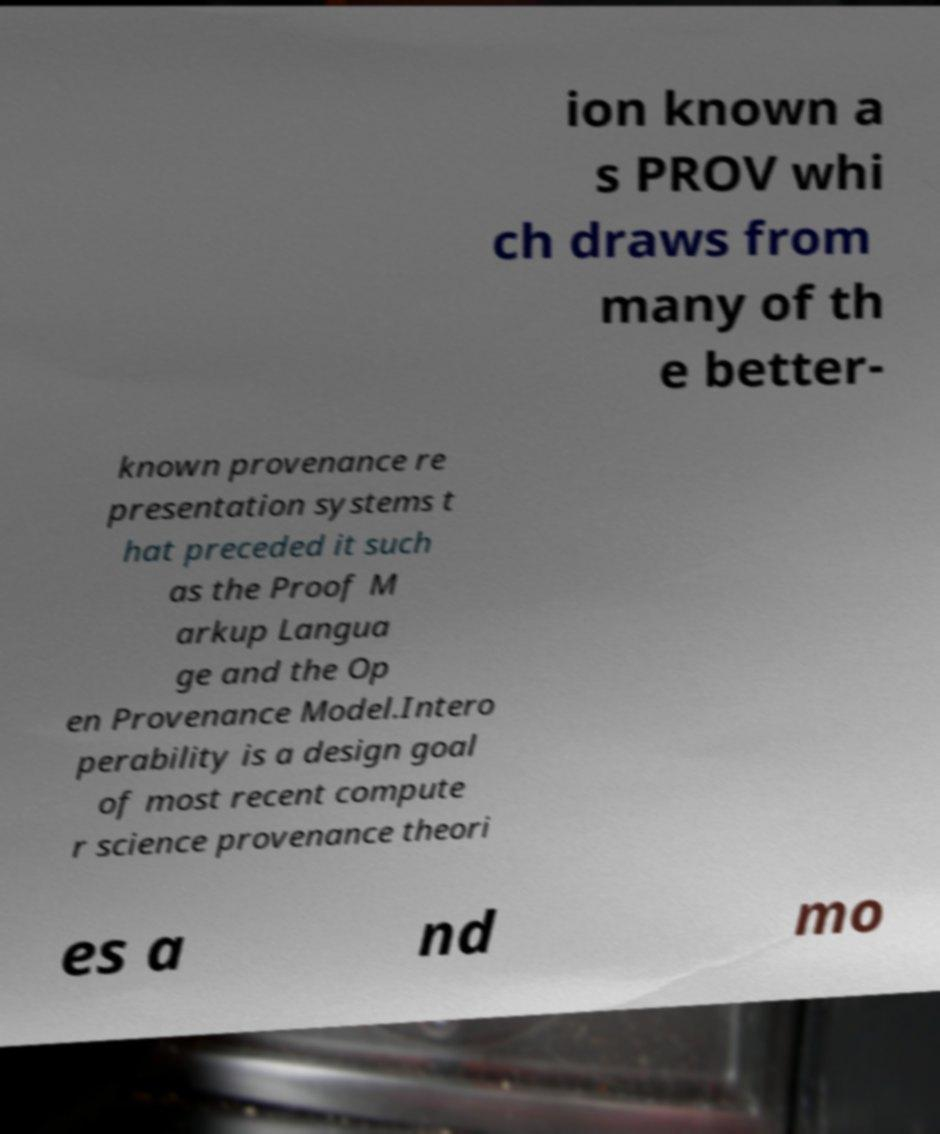I need the written content from this picture converted into text. Can you do that? ion known a s PROV whi ch draws from many of th e better- known provenance re presentation systems t hat preceded it such as the Proof M arkup Langua ge and the Op en Provenance Model.Intero perability is a design goal of most recent compute r science provenance theori es a nd mo 